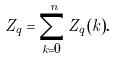<formula> <loc_0><loc_0><loc_500><loc_500>Z _ { q } = \sum _ { k = 0 } ^ { n } Z _ { q } ( k ) .</formula> 